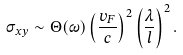<formula> <loc_0><loc_0><loc_500><loc_500>\sigma _ { x y } \sim \Theta ( \omega ) \left ( \frac { v _ { F } } { c } \right ) ^ { 2 } \left ( \frac { \lambda } { l } \right ) ^ { 2 } .</formula> 